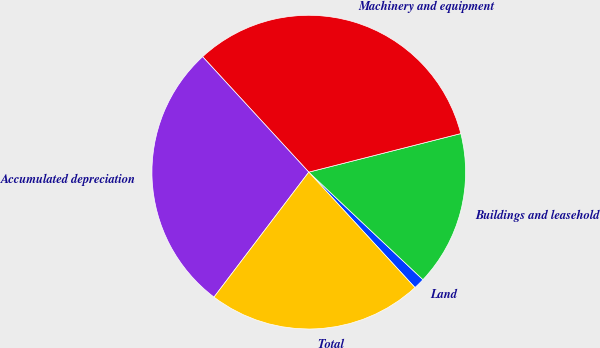Convert chart. <chart><loc_0><loc_0><loc_500><loc_500><pie_chart><fcel>Land<fcel>Buildings and leasehold<fcel>Machinery and equipment<fcel>Accumulated depreciation<fcel>Total<nl><fcel>1.14%<fcel>15.98%<fcel>32.88%<fcel>27.84%<fcel>22.16%<nl></chart> 